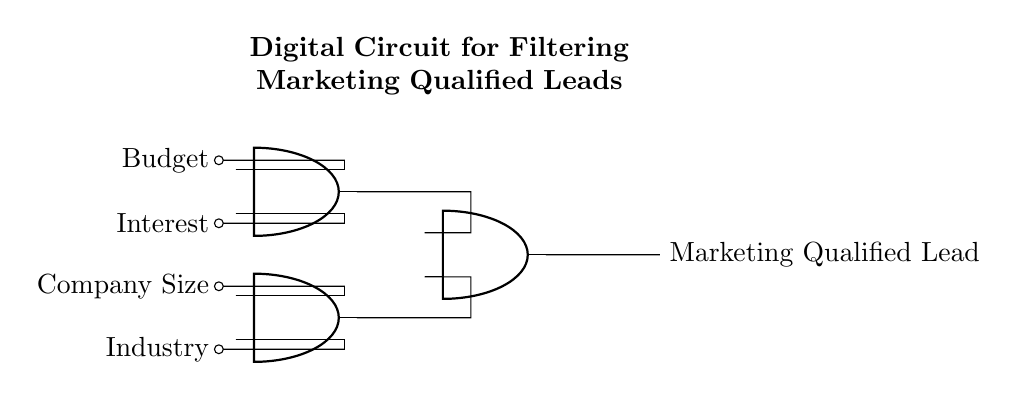What are the inputs of the first AND gate? The inputs of the first AND gate are Budget and Interest. These signals are represented as the nodes connected to the top two inputs of the AND gate.
Answer: Budget, Interest What is the output of the second AND gate? The output of the second AND gate is connected to the input of the third AND gate and ultimately leads to the final output labeled "Marketing Qualified Lead." The output of this AND gate processes inputs from Company Size and Industry.
Answer: Second AND gate output connects to third AND gate How many AND gates are there in this circuit? The diagram shows three AND gates, as indicated by the three AND gate symbols present in the circuit.
Answer: Three What is the final output of the circuit? The final output of the circuit is labeled as "Marketing Qualified Lead," which signifies the result after processing all input conditions through the AND gates.
Answer: Marketing Qualified Lead What are the two input signals connected to the second AND gate? The second AND gate receives inputs from Company Size and Industry. These are the lower two input signals connected to its input terminals.
Answer: Company Size, Industry Why does the circuit require multiple AND gates? Multiple AND gates allow for more complex filtering of marketing qualified leads by combining several input conditions. Each AND gate ensures that the conditions fed into them must all be satisfied for a positive output to occur, which is essential in determining the quality of leads based on multiple criteria.
Answer: To satisfy multiple conditions 